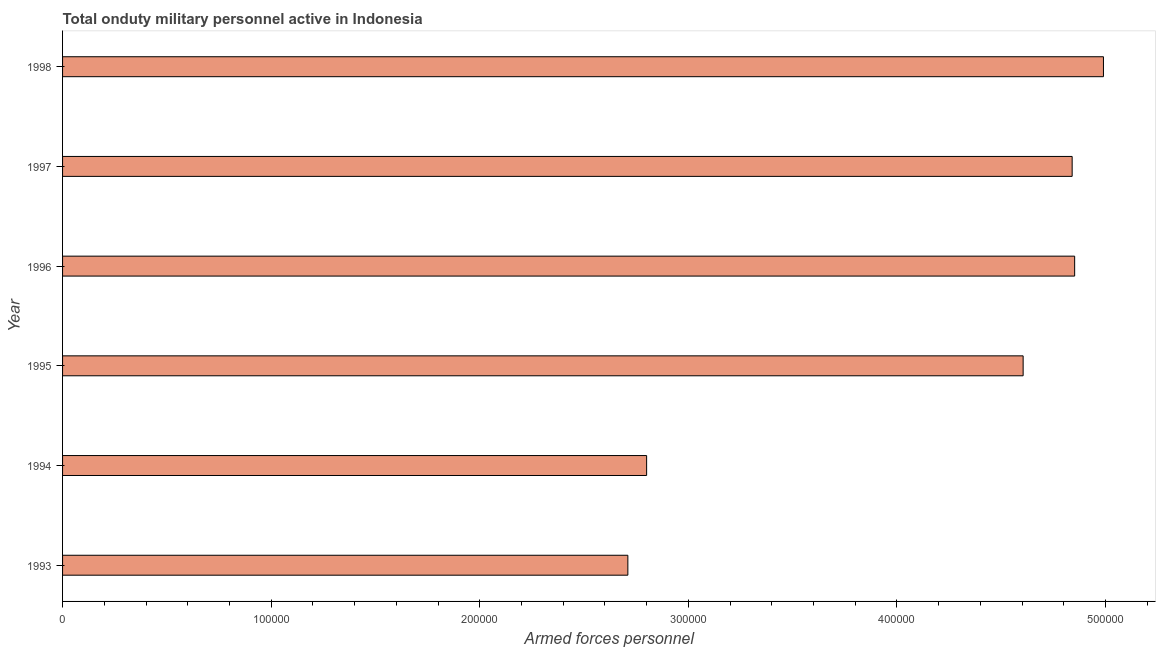Does the graph contain any zero values?
Make the answer very short. No. Does the graph contain grids?
Provide a succinct answer. No. What is the title of the graph?
Offer a very short reply. Total onduty military personnel active in Indonesia. What is the label or title of the X-axis?
Make the answer very short. Armed forces personnel. What is the label or title of the Y-axis?
Ensure brevity in your answer.  Year. Across all years, what is the maximum number of armed forces personnel?
Ensure brevity in your answer.  4.99e+05. Across all years, what is the minimum number of armed forces personnel?
Your answer should be very brief. 2.71e+05. In which year was the number of armed forces personnel minimum?
Provide a short and direct response. 1993. What is the sum of the number of armed forces personnel?
Keep it short and to the point. 2.48e+06. What is the difference between the number of armed forces personnel in 1994 and 1996?
Keep it short and to the point. -2.05e+05. What is the average number of armed forces personnel per year?
Offer a terse response. 4.13e+05. What is the median number of armed forces personnel?
Your answer should be very brief. 4.72e+05. In how many years, is the number of armed forces personnel greater than 200000 ?
Offer a terse response. 6. Do a majority of the years between 1993 and 1996 (inclusive) have number of armed forces personnel greater than 480000 ?
Offer a terse response. No. What is the ratio of the number of armed forces personnel in 1996 to that in 1997?
Provide a succinct answer. 1. Is the number of armed forces personnel in 1996 less than that in 1998?
Provide a succinct answer. Yes. Is the difference between the number of armed forces personnel in 1997 and 1998 greater than the difference between any two years?
Make the answer very short. No. What is the difference between the highest and the second highest number of armed forces personnel?
Make the answer very short. 1.38e+04. Is the sum of the number of armed forces personnel in 1994 and 1995 greater than the maximum number of armed forces personnel across all years?
Make the answer very short. Yes. What is the difference between the highest and the lowest number of armed forces personnel?
Provide a short and direct response. 2.28e+05. In how many years, is the number of armed forces personnel greater than the average number of armed forces personnel taken over all years?
Give a very brief answer. 4. Are all the bars in the graph horizontal?
Keep it short and to the point. Yes. How many years are there in the graph?
Give a very brief answer. 6. What is the Armed forces personnel in 1993?
Your response must be concise. 2.71e+05. What is the Armed forces personnel of 1995?
Your answer should be very brief. 4.60e+05. What is the Armed forces personnel in 1996?
Provide a short and direct response. 4.85e+05. What is the Armed forces personnel of 1997?
Make the answer very short. 4.84e+05. What is the Armed forces personnel in 1998?
Give a very brief answer. 4.99e+05. What is the difference between the Armed forces personnel in 1993 and 1994?
Provide a succinct answer. -9000. What is the difference between the Armed forces personnel in 1993 and 1995?
Make the answer very short. -1.90e+05. What is the difference between the Armed forces personnel in 1993 and 1996?
Offer a very short reply. -2.14e+05. What is the difference between the Armed forces personnel in 1993 and 1997?
Your response must be concise. -2.13e+05. What is the difference between the Armed forces personnel in 1993 and 1998?
Offer a very short reply. -2.28e+05. What is the difference between the Armed forces personnel in 1994 and 1995?
Make the answer very short. -1.80e+05. What is the difference between the Armed forces personnel in 1994 and 1996?
Offer a terse response. -2.05e+05. What is the difference between the Armed forces personnel in 1994 and 1997?
Give a very brief answer. -2.04e+05. What is the difference between the Armed forces personnel in 1994 and 1998?
Make the answer very short. -2.19e+05. What is the difference between the Armed forces personnel in 1995 and 1996?
Ensure brevity in your answer.  -2.47e+04. What is the difference between the Armed forces personnel in 1995 and 1997?
Your answer should be compact. -2.35e+04. What is the difference between the Armed forces personnel in 1995 and 1998?
Your response must be concise. -3.85e+04. What is the difference between the Armed forces personnel in 1996 and 1997?
Give a very brief answer. 1200. What is the difference between the Armed forces personnel in 1996 and 1998?
Give a very brief answer. -1.38e+04. What is the difference between the Armed forces personnel in 1997 and 1998?
Offer a very short reply. -1.50e+04. What is the ratio of the Armed forces personnel in 1993 to that in 1995?
Provide a succinct answer. 0.59. What is the ratio of the Armed forces personnel in 1993 to that in 1996?
Ensure brevity in your answer.  0.56. What is the ratio of the Armed forces personnel in 1993 to that in 1997?
Make the answer very short. 0.56. What is the ratio of the Armed forces personnel in 1993 to that in 1998?
Offer a terse response. 0.54. What is the ratio of the Armed forces personnel in 1994 to that in 1995?
Make the answer very short. 0.61. What is the ratio of the Armed forces personnel in 1994 to that in 1996?
Make the answer very short. 0.58. What is the ratio of the Armed forces personnel in 1994 to that in 1997?
Ensure brevity in your answer.  0.58. What is the ratio of the Armed forces personnel in 1994 to that in 1998?
Offer a terse response. 0.56. What is the ratio of the Armed forces personnel in 1995 to that in 1996?
Your answer should be compact. 0.95. What is the ratio of the Armed forces personnel in 1995 to that in 1997?
Your response must be concise. 0.95. What is the ratio of the Armed forces personnel in 1995 to that in 1998?
Provide a short and direct response. 0.92. 